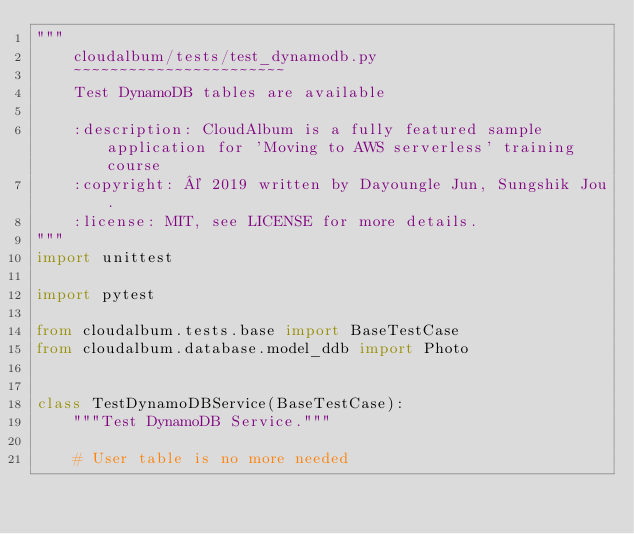Convert code to text. <code><loc_0><loc_0><loc_500><loc_500><_Python_>"""
    cloudalbum/tests/test_dynamodb.py
    ~~~~~~~~~~~~~~~~~~~~~~~
    Test DynamoDB tables are available

    :description: CloudAlbum is a fully featured sample application for 'Moving to AWS serverless' training course
    :copyright: © 2019 written by Dayoungle Jun, Sungshik Jou.
    :license: MIT, see LICENSE for more details.
"""
import unittest

import pytest

from cloudalbum.tests.base import BaseTestCase
from cloudalbum.database.model_ddb import Photo


class TestDynamoDBService(BaseTestCase):
    """Test DynamoDB Service."""

    # User table is no more needed</code> 